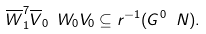Convert formula to latex. <formula><loc_0><loc_0><loc_500><loc_500>\overline { W } ^ { 7 } _ { 1 } \overline { V } _ { 0 } \ W _ { 0 } V _ { 0 } \subseteq r ^ { - 1 } ( G ^ { 0 } \ N ) .</formula> 